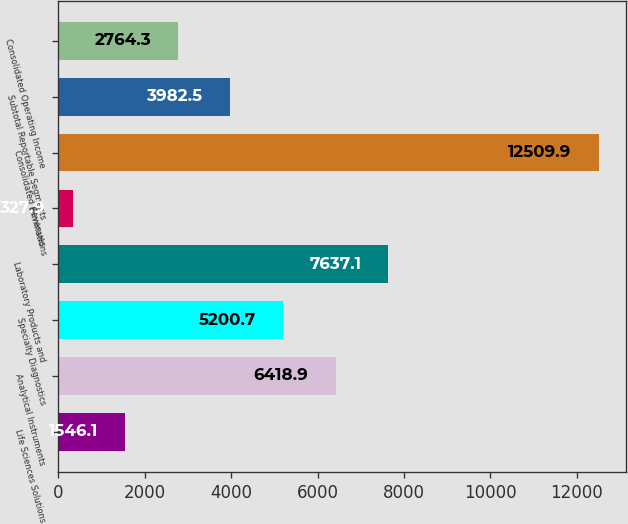Convert chart to OTSL. <chart><loc_0><loc_0><loc_500><loc_500><bar_chart><fcel>Life Sciences Solutions<fcel>Analytical Instruments<fcel>Specialty Diagnostics<fcel>Laboratory Products and<fcel>Eliminations<fcel>Consolidated Revenues<fcel>Subtotal Reportable Segments<fcel>Consolidated Operating Income<nl><fcel>1546.1<fcel>6418.9<fcel>5200.7<fcel>7637.1<fcel>327.9<fcel>12509.9<fcel>3982.5<fcel>2764.3<nl></chart> 